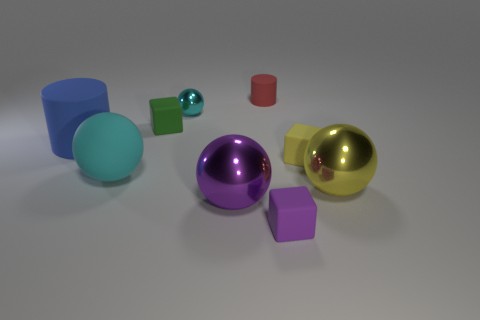There is another object that is the same shape as the red thing; what size is it?
Provide a short and direct response. Large. Are there any objects of the same color as the tiny shiny sphere?
Provide a succinct answer. Yes. There is a small sphere that is the same color as the large rubber sphere; what is it made of?
Offer a very short reply. Metal. What number of small objects have the same color as the large matte sphere?
Ensure brevity in your answer.  1. How many things are either cylinders on the left side of the small cyan metallic ball or big cylinders?
Provide a succinct answer. 1. There is a big cylinder that is the same material as the small yellow thing; what is its color?
Your response must be concise. Blue. Are there any cyan metallic cubes of the same size as the red rubber cylinder?
Offer a terse response. No. How many objects are tiny rubber cubes that are in front of the blue thing or small cyan spheres on the left side of the large purple sphere?
Provide a short and direct response. 3. There is a green matte thing that is the same size as the yellow block; what is its shape?
Offer a very short reply. Cube. Are there any large cyan metallic things of the same shape as the tiny cyan metal thing?
Make the answer very short. No. 